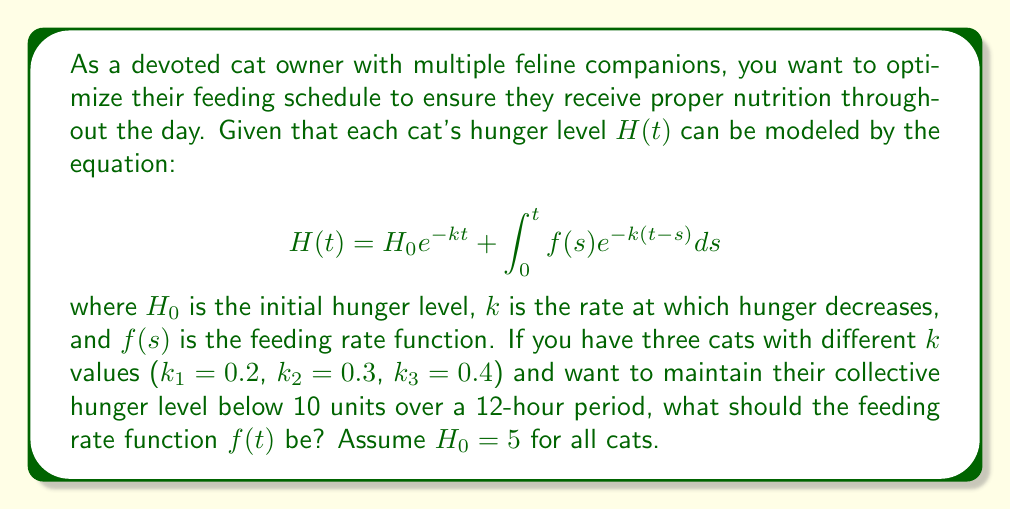Can you answer this question? To solve this problem, we need to follow these steps:

1) First, we need to set up the integral equation for the total hunger level of all three cats:

   $$H_{total}(t) = \sum_{i=1}^3 (5e^{-k_it} + \int_0^t f(s)e^{-k_i(t-s)}ds)$$

2) We want this total hunger to be less than 10 at all times:

   $$H_{total}(t) < 10 \quad \forall t \in [0, 12]$$

3) To simplify, let's assume a constant feeding rate $f(t) = C$. This gives us:

   $$\sum_{i=1}^3 (5e^{-k_it} + C\int_0^t e^{-k_i(t-s)}ds) < 10$$

4) Solving the integral:

   $$\sum_{i=1}^3 (5e^{-k_it} + \frac{C}{k_i}(1-e^{-k_it})) < 10$$

5) At $t=12$ (worst case), this becomes:

   $$5(e^{-2.4} + e^{-3.6} + e^{-4.8}) + C(\frac{1-e^{-2.4}}{0.2} + \frac{1-e^{-3.6}}{0.3} + \frac{1-e^{-4.8}}{0.4}) < 10$$

6) Simplifying:

   $$0.1839 + 14.2198C < 10$$

7) Solving for C:

   $$C < 0.6903$$

Therefore, a constant feeding rate of slightly less than 0.6903 units per hour will keep the total hunger level below 10 at all times.
Answer: $f(t) = 0.69$ units/hour 